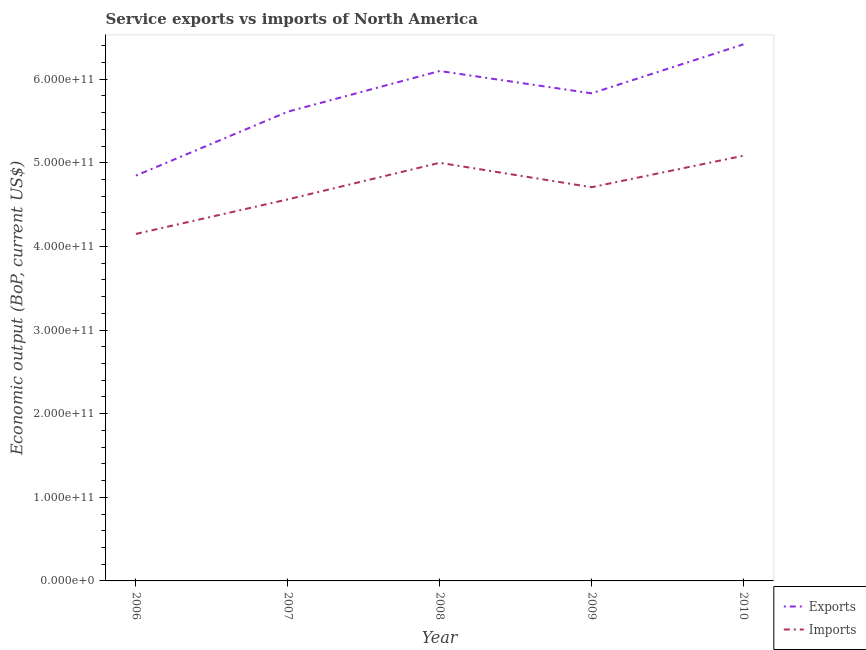How many different coloured lines are there?
Keep it short and to the point. 2. Is the number of lines equal to the number of legend labels?
Your answer should be compact. Yes. What is the amount of service imports in 2008?
Your answer should be very brief. 5.00e+11. Across all years, what is the maximum amount of service imports?
Keep it short and to the point. 5.09e+11. Across all years, what is the minimum amount of service imports?
Provide a succinct answer. 4.15e+11. What is the total amount of service exports in the graph?
Give a very brief answer. 2.88e+12. What is the difference between the amount of service imports in 2006 and that in 2010?
Make the answer very short. -9.35e+1. What is the difference between the amount of service exports in 2010 and the amount of service imports in 2009?
Make the answer very short. 1.71e+11. What is the average amount of service exports per year?
Offer a very short reply. 5.76e+11. In the year 2008, what is the difference between the amount of service imports and amount of service exports?
Your response must be concise. -1.10e+11. In how many years, is the amount of service imports greater than 500000000000 US$?
Ensure brevity in your answer.  2. What is the ratio of the amount of service imports in 2006 to that in 2007?
Your answer should be very brief. 0.91. Is the difference between the amount of service imports in 2007 and 2008 greater than the difference between the amount of service exports in 2007 and 2008?
Make the answer very short. Yes. What is the difference between the highest and the second highest amount of service exports?
Provide a short and direct response. 3.19e+1. What is the difference between the highest and the lowest amount of service exports?
Ensure brevity in your answer.  1.57e+11. In how many years, is the amount of service exports greater than the average amount of service exports taken over all years?
Your response must be concise. 3. Is the sum of the amount of service exports in 2007 and 2008 greater than the maximum amount of service imports across all years?
Make the answer very short. Yes. Is the amount of service imports strictly greater than the amount of service exports over the years?
Give a very brief answer. No. Is the amount of service imports strictly less than the amount of service exports over the years?
Provide a short and direct response. Yes. What is the difference between two consecutive major ticks on the Y-axis?
Keep it short and to the point. 1.00e+11. Are the values on the major ticks of Y-axis written in scientific E-notation?
Provide a short and direct response. Yes. Does the graph contain any zero values?
Ensure brevity in your answer.  No. Does the graph contain grids?
Your response must be concise. No. How are the legend labels stacked?
Provide a succinct answer. Vertical. What is the title of the graph?
Make the answer very short. Service exports vs imports of North America. What is the label or title of the X-axis?
Keep it short and to the point. Year. What is the label or title of the Y-axis?
Give a very brief answer. Economic output (BoP, current US$). What is the Economic output (BoP, current US$) in Exports in 2006?
Your answer should be compact. 4.85e+11. What is the Economic output (BoP, current US$) in Imports in 2006?
Your answer should be compact. 4.15e+11. What is the Economic output (BoP, current US$) of Exports in 2007?
Keep it short and to the point. 5.61e+11. What is the Economic output (BoP, current US$) of Imports in 2007?
Your response must be concise. 4.56e+11. What is the Economic output (BoP, current US$) of Exports in 2008?
Your answer should be very brief. 6.10e+11. What is the Economic output (BoP, current US$) in Imports in 2008?
Provide a short and direct response. 5.00e+11. What is the Economic output (BoP, current US$) of Exports in 2009?
Provide a succinct answer. 5.83e+11. What is the Economic output (BoP, current US$) of Imports in 2009?
Your response must be concise. 4.71e+11. What is the Economic output (BoP, current US$) of Exports in 2010?
Your answer should be very brief. 6.42e+11. What is the Economic output (BoP, current US$) in Imports in 2010?
Keep it short and to the point. 5.09e+11. Across all years, what is the maximum Economic output (BoP, current US$) in Exports?
Provide a short and direct response. 6.42e+11. Across all years, what is the maximum Economic output (BoP, current US$) of Imports?
Your answer should be compact. 5.09e+11. Across all years, what is the minimum Economic output (BoP, current US$) in Exports?
Provide a short and direct response. 4.85e+11. Across all years, what is the minimum Economic output (BoP, current US$) in Imports?
Your response must be concise. 4.15e+11. What is the total Economic output (BoP, current US$) in Exports in the graph?
Ensure brevity in your answer.  2.88e+12. What is the total Economic output (BoP, current US$) in Imports in the graph?
Offer a terse response. 2.35e+12. What is the difference between the Economic output (BoP, current US$) of Exports in 2006 and that in 2007?
Your response must be concise. -7.64e+1. What is the difference between the Economic output (BoP, current US$) in Imports in 2006 and that in 2007?
Ensure brevity in your answer.  -4.13e+1. What is the difference between the Economic output (BoP, current US$) in Exports in 2006 and that in 2008?
Your answer should be very brief. -1.25e+11. What is the difference between the Economic output (BoP, current US$) of Imports in 2006 and that in 2008?
Provide a short and direct response. -8.51e+1. What is the difference between the Economic output (BoP, current US$) in Exports in 2006 and that in 2009?
Offer a terse response. -9.84e+1. What is the difference between the Economic output (BoP, current US$) in Imports in 2006 and that in 2009?
Make the answer very short. -5.58e+1. What is the difference between the Economic output (BoP, current US$) of Exports in 2006 and that in 2010?
Your answer should be very brief. -1.57e+11. What is the difference between the Economic output (BoP, current US$) of Imports in 2006 and that in 2010?
Offer a terse response. -9.35e+1. What is the difference between the Economic output (BoP, current US$) in Exports in 2007 and that in 2008?
Provide a short and direct response. -4.86e+1. What is the difference between the Economic output (BoP, current US$) of Imports in 2007 and that in 2008?
Offer a very short reply. -4.38e+1. What is the difference between the Economic output (BoP, current US$) in Exports in 2007 and that in 2009?
Give a very brief answer. -2.19e+1. What is the difference between the Economic output (BoP, current US$) in Imports in 2007 and that in 2009?
Your response must be concise. -1.46e+1. What is the difference between the Economic output (BoP, current US$) of Exports in 2007 and that in 2010?
Make the answer very short. -8.05e+1. What is the difference between the Economic output (BoP, current US$) in Imports in 2007 and that in 2010?
Keep it short and to the point. -5.22e+1. What is the difference between the Economic output (BoP, current US$) in Exports in 2008 and that in 2009?
Your answer should be very brief. 2.67e+1. What is the difference between the Economic output (BoP, current US$) in Imports in 2008 and that in 2009?
Your answer should be very brief. 2.92e+1. What is the difference between the Economic output (BoP, current US$) of Exports in 2008 and that in 2010?
Offer a terse response. -3.19e+1. What is the difference between the Economic output (BoP, current US$) of Imports in 2008 and that in 2010?
Your answer should be compact. -8.48e+09. What is the difference between the Economic output (BoP, current US$) in Exports in 2009 and that in 2010?
Provide a short and direct response. -5.86e+1. What is the difference between the Economic output (BoP, current US$) in Imports in 2009 and that in 2010?
Provide a short and direct response. -3.77e+1. What is the difference between the Economic output (BoP, current US$) in Exports in 2006 and the Economic output (BoP, current US$) in Imports in 2007?
Your answer should be very brief. 2.84e+1. What is the difference between the Economic output (BoP, current US$) of Exports in 2006 and the Economic output (BoP, current US$) of Imports in 2008?
Give a very brief answer. -1.53e+1. What is the difference between the Economic output (BoP, current US$) in Exports in 2006 and the Economic output (BoP, current US$) in Imports in 2009?
Ensure brevity in your answer.  1.39e+1. What is the difference between the Economic output (BoP, current US$) in Exports in 2006 and the Economic output (BoP, current US$) in Imports in 2010?
Give a very brief answer. -2.38e+1. What is the difference between the Economic output (BoP, current US$) in Exports in 2007 and the Economic output (BoP, current US$) in Imports in 2008?
Ensure brevity in your answer.  6.11e+1. What is the difference between the Economic output (BoP, current US$) of Exports in 2007 and the Economic output (BoP, current US$) of Imports in 2009?
Provide a short and direct response. 9.03e+1. What is the difference between the Economic output (BoP, current US$) in Exports in 2007 and the Economic output (BoP, current US$) in Imports in 2010?
Provide a short and direct response. 5.26e+1. What is the difference between the Economic output (BoP, current US$) of Exports in 2008 and the Economic output (BoP, current US$) of Imports in 2009?
Offer a terse response. 1.39e+11. What is the difference between the Economic output (BoP, current US$) of Exports in 2008 and the Economic output (BoP, current US$) of Imports in 2010?
Keep it short and to the point. 1.01e+11. What is the difference between the Economic output (BoP, current US$) of Exports in 2009 and the Economic output (BoP, current US$) of Imports in 2010?
Your response must be concise. 7.46e+1. What is the average Economic output (BoP, current US$) of Exports per year?
Provide a succinct answer. 5.76e+11. What is the average Economic output (BoP, current US$) in Imports per year?
Ensure brevity in your answer.  4.70e+11. In the year 2006, what is the difference between the Economic output (BoP, current US$) in Exports and Economic output (BoP, current US$) in Imports?
Your answer should be compact. 6.97e+1. In the year 2007, what is the difference between the Economic output (BoP, current US$) of Exports and Economic output (BoP, current US$) of Imports?
Give a very brief answer. 1.05e+11. In the year 2008, what is the difference between the Economic output (BoP, current US$) of Exports and Economic output (BoP, current US$) of Imports?
Provide a short and direct response. 1.10e+11. In the year 2009, what is the difference between the Economic output (BoP, current US$) in Exports and Economic output (BoP, current US$) in Imports?
Provide a succinct answer. 1.12e+11. In the year 2010, what is the difference between the Economic output (BoP, current US$) in Exports and Economic output (BoP, current US$) in Imports?
Make the answer very short. 1.33e+11. What is the ratio of the Economic output (BoP, current US$) of Exports in 2006 to that in 2007?
Give a very brief answer. 0.86. What is the ratio of the Economic output (BoP, current US$) in Imports in 2006 to that in 2007?
Your response must be concise. 0.91. What is the ratio of the Economic output (BoP, current US$) of Exports in 2006 to that in 2008?
Offer a terse response. 0.79. What is the ratio of the Economic output (BoP, current US$) of Imports in 2006 to that in 2008?
Make the answer very short. 0.83. What is the ratio of the Economic output (BoP, current US$) in Exports in 2006 to that in 2009?
Provide a succinct answer. 0.83. What is the ratio of the Economic output (BoP, current US$) in Imports in 2006 to that in 2009?
Provide a succinct answer. 0.88. What is the ratio of the Economic output (BoP, current US$) of Exports in 2006 to that in 2010?
Your response must be concise. 0.76. What is the ratio of the Economic output (BoP, current US$) in Imports in 2006 to that in 2010?
Offer a very short reply. 0.82. What is the ratio of the Economic output (BoP, current US$) in Exports in 2007 to that in 2008?
Give a very brief answer. 0.92. What is the ratio of the Economic output (BoP, current US$) of Imports in 2007 to that in 2008?
Your answer should be very brief. 0.91. What is the ratio of the Economic output (BoP, current US$) in Exports in 2007 to that in 2009?
Your answer should be compact. 0.96. What is the ratio of the Economic output (BoP, current US$) in Imports in 2007 to that in 2009?
Offer a terse response. 0.97. What is the ratio of the Economic output (BoP, current US$) in Exports in 2007 to that in 2010?
Keep it short and to the point. 0.87. What is the ratio of the Economic output (BoP, current US$) in Imports in 2007 to that in 2010?
Your answer should be compact. 0.9. What is the ratio of the Economic output (BoP, current US$) of Exports in 2008 to that in 2009?
Ensure brevity in your answer.  1.05. What is the ratio of the Economic output (BoP, current US$) in Imports in 2008 to that in 2009?
Your response must be concise. 1.06. What is the ratio of the Economic output (BoP, current US$) in Exports in 2008 to that in 2010?
Offer a terse response. 0.95. What is the ratio of the Economic output (BoP, current US$) in Imports in 2008 to that in 2010?
Offer a terse response. 0.98. What is the ratio of the Economic output (BoP, current US$) of Exports in 2009 to that in 2010?
Offer a very short reply. 0.91. What is the ratio of the Economic output (BoP, current US$) of Imports in 2009 to that in 2010?
Your response must be concise. 0.93. What is the difference between the highest and the second highest Economic output (BoP, current US$) in Exports?
Your answer should be very brief. 3.19e+1. What is the difference between the highest and the second highest Economic output (BoP, current US$) in Imports?
Offer a very short reply. 8.48e+09. What is the difference between the highest and the lowest Economic output (BoP, current US$) of Exports?
Your answer should be very brief. 1.57e+11. What is the difference between the highest and the lowest Economic output (BoP, current US$) of Imports?
Offer a terse response. 9.35e+1. 